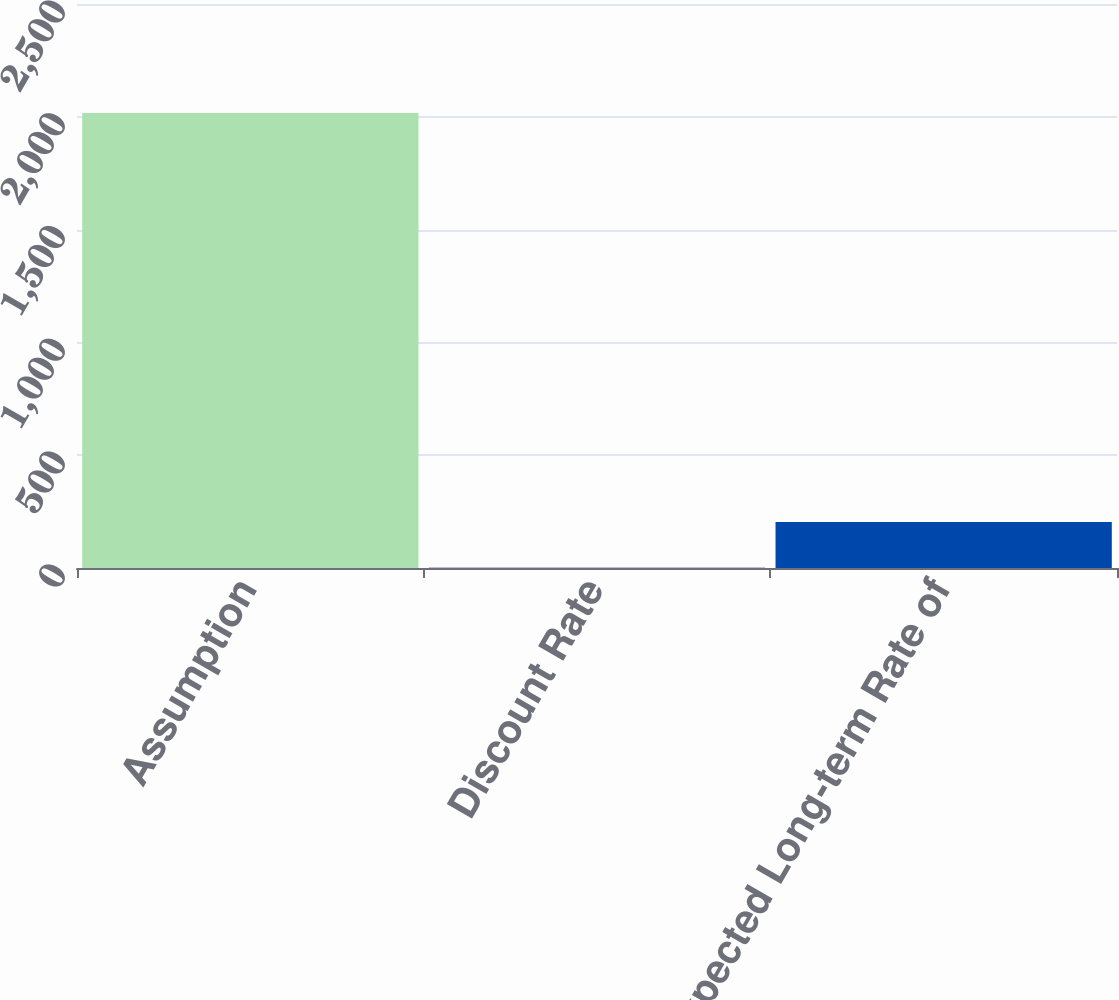Convert chart to OTSL. <chart><loc_0><loc_0><loc_500><loc_500><bar_chart><fcel>Assumption<fcel>Discount Rate<fcel>Expected Long-term Rate of<nl><fcel>2017<fcel>2.7<fcel>204.13<nl></chart> 